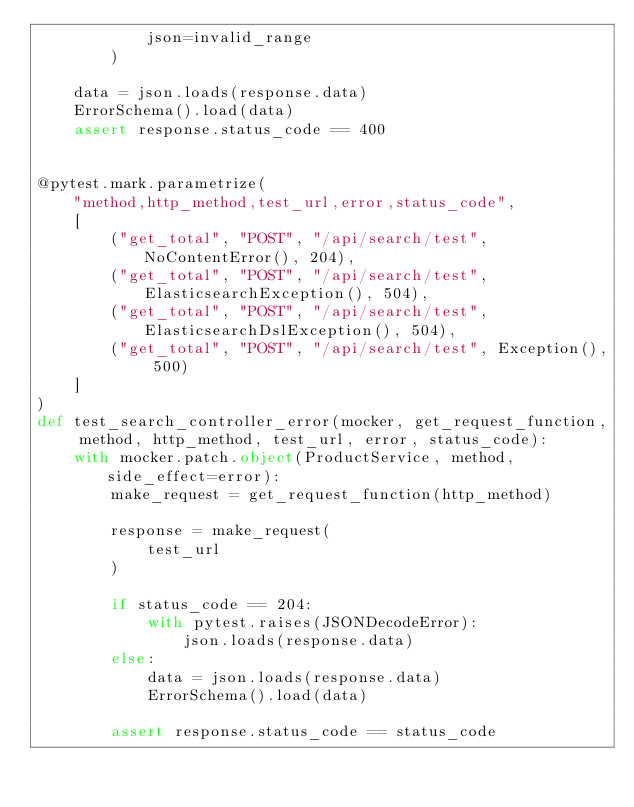Convert code to text. <code><loc_0><loc_0><loc_500><loc_500><_Python_>            json=invalid_range
        )

    data = json.loads(response.data)
    ErrorSchema().load(data)
    assert response.status_code == 400


@pytest.mark.parametrize(
    "method,http_method,test_url,error,status_code",
    [
        ("get_total", "POST", "/api/search/test", NoContentError(), 204),
        ("get_total", "POST", "/api/search/test", ElasticsearchException(), 504),
        ("get_total", "POST", "/api/search/test", ElasticsearchDslException(), 504),
        ("get_total", "POST", "/api/search/test", Exception(), 500)
    ]
)
def test_search_controller_error(mocker, get_request_function, method, http_method, test_url, error, status_code):
    with mocker.patch.object(ProductService, method, side_effect=error):
        make_request = get_request_function(http_method)

        response = make_request(
            test_url
        )

        if status_code == 204:
            with pytest.raises(JSONDecodeError):
                json.loads(response.data)
        else:
            data = json.loads(response.data)
            ErrorSchema().load(data)

        assert response.status_code == status_code
</code> 